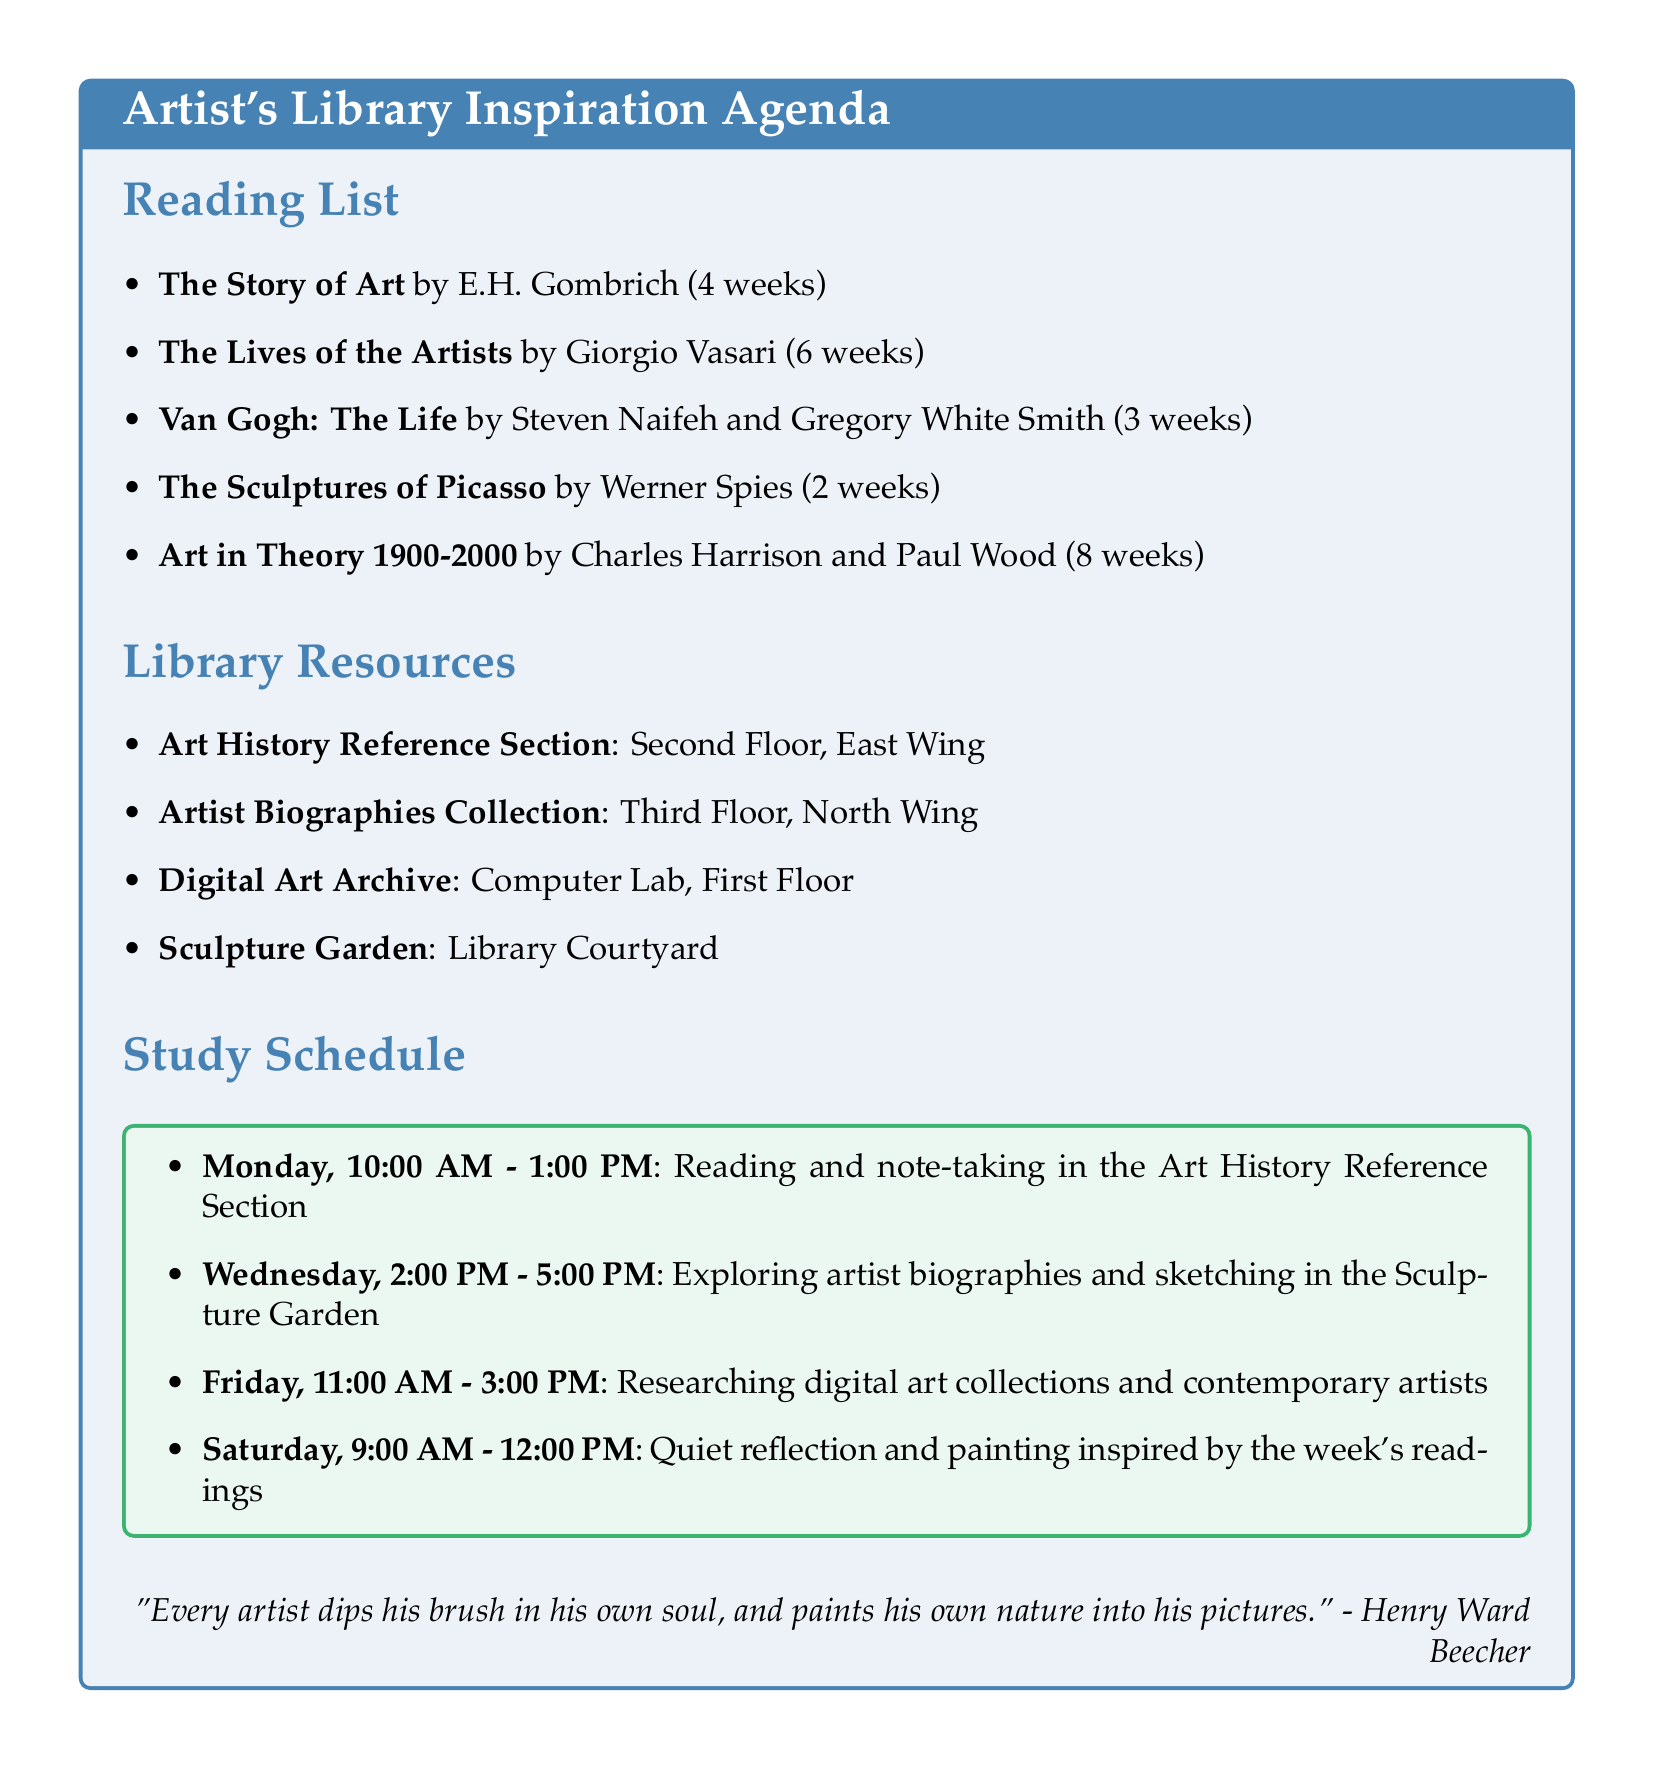What is the title of the book by E.H. Gombrich? The title of E.H. Gombrich's book is provided in the reading list section.
Answer: The Story of Art How many weeks is the completion target for "The Sculptures of Picasso"? The completion target for "The Sculptures of Picasso" is stated in weeks in the reading list section.
Answer: 2 weeks Where is the Art History Reference Section located? The location of the Art History Reference Section is mentioned under library resources.
Answer: Second Floor, East Wing Which author's work is featured in the study schedule on Friday? The study schedule lists activities for each day, and the author featured on Friday is implied through the research theme.
Answer: Contemporary artists What is the purpose of "The Diary of Frida Kahlo"? The relevance of "The Diary of Frida Kahlo" provides insight into its purpose in the context of art and self-reflection.
Answer: Inspiring for self-reflection in art What day and time is designated for quiet reflection and painting? The study schedule specifically outlines the day and time for quiet reflection and painting, indicating when this activity occurs.
Answer: Saturday, 9:00 AM - 12:00 PM Which resource provides access to online digital art collections? The document lists various library resources, and the one for online collections is explicitly mentioned.
Answer: Digital Art Archive How long is the completion target for "Art in Theory 1900-2000"? The duration for completing "Art in Theory 1900-2000" is included in the reading list.
Answer: 8 weeks 